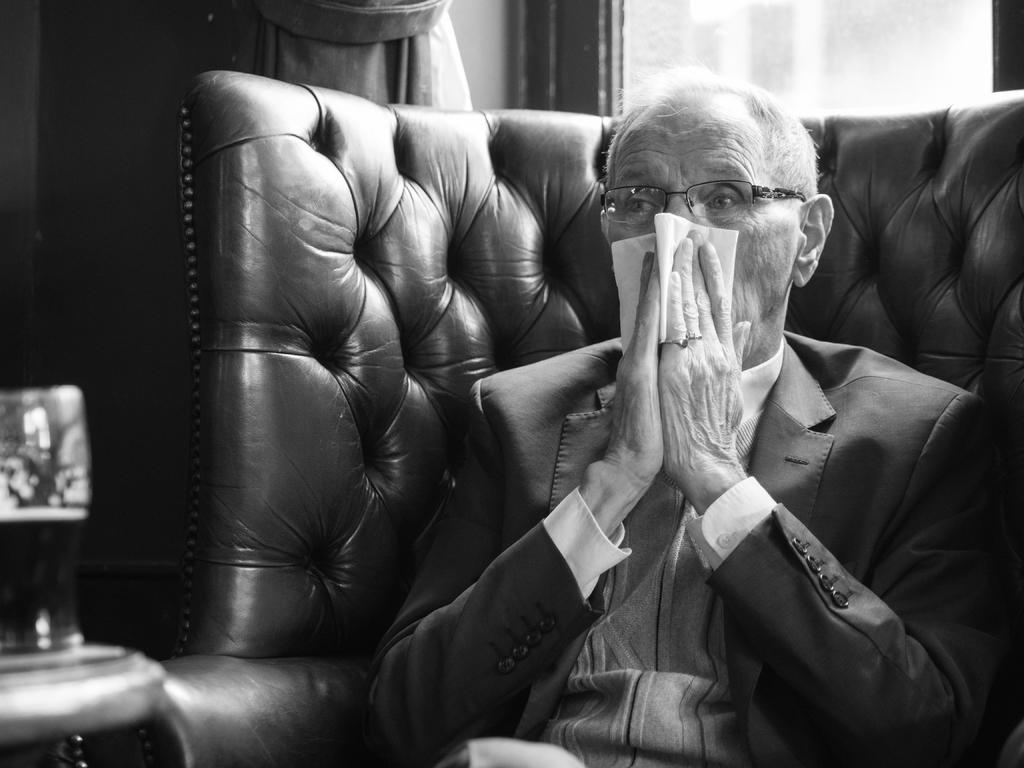What is the color scheme of the image? The image is black and white. What piece of furniture is present in the image? There is a chair in the image. Who is sitting on the chair? An old man is sitting on the chair. What is the old man wearing? The old man is wearing a blazer and glasses (specs). What is the old man holding in his hands? The old man is holding a kerchief in his hands. What type of feather can be seen on the old man's hat in the image? There is no hat present on the old man in the image, let alone a feather on it. 